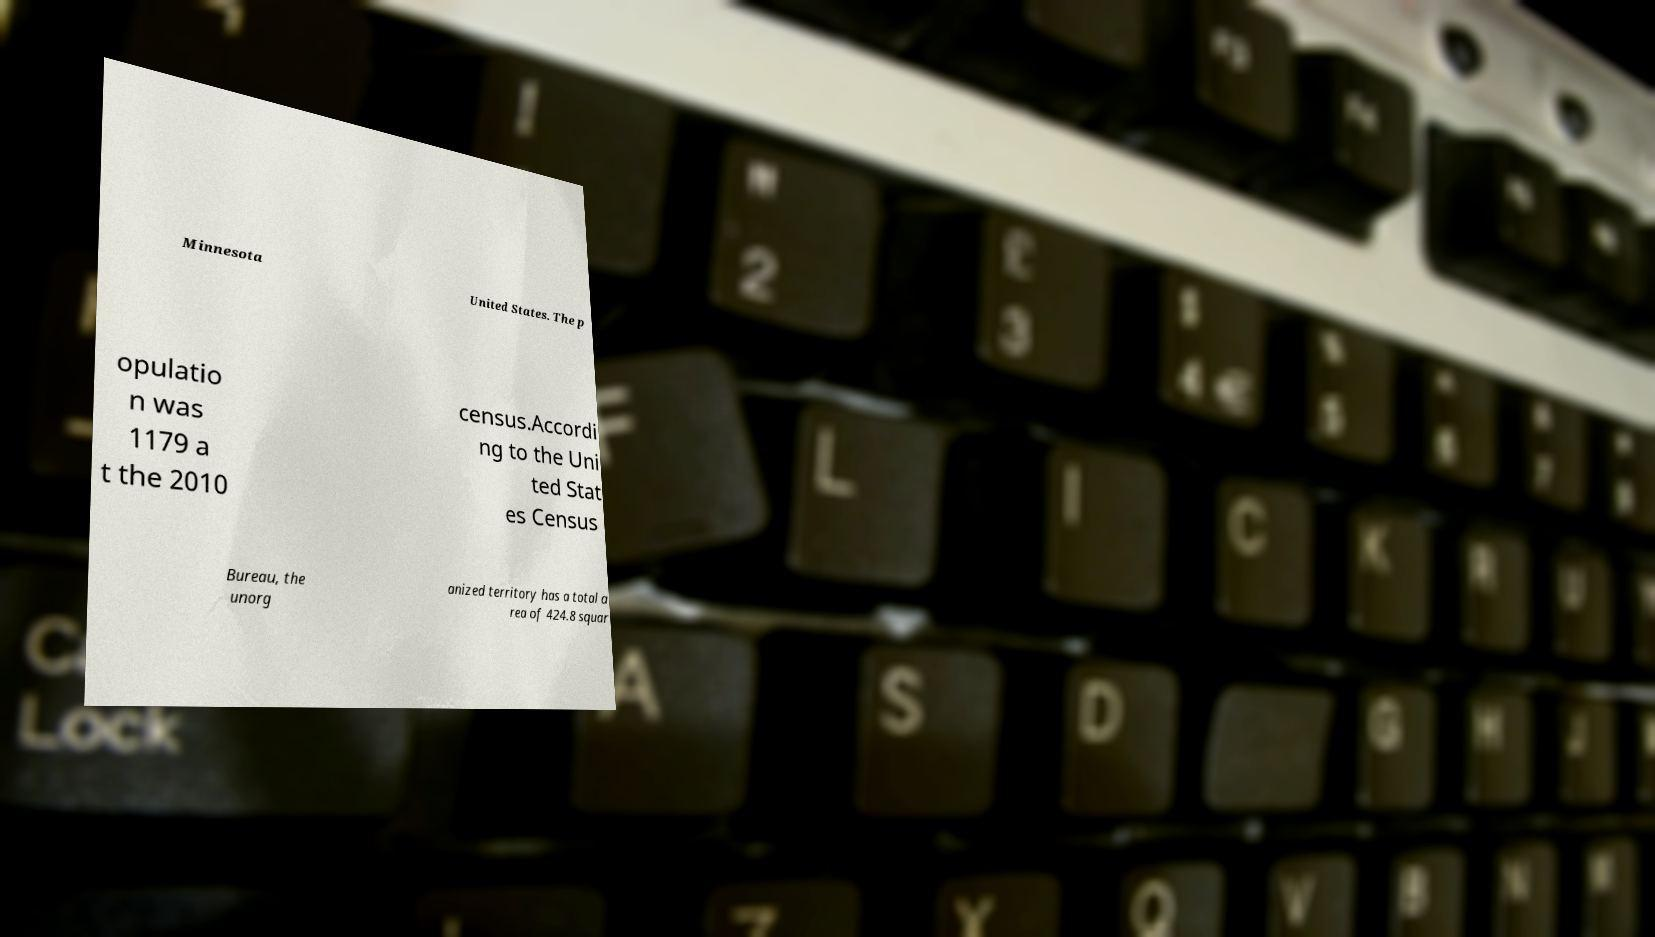What messages or text are displayed in this image? I need them in a readable, typed format. Minnesota United States. The p opulatio n was 1179 a t the 2010 census.Accordi ng to the Uni ted Stat es Census Bureau, the unorg anized territory has a total a rea of 424.8 squar 